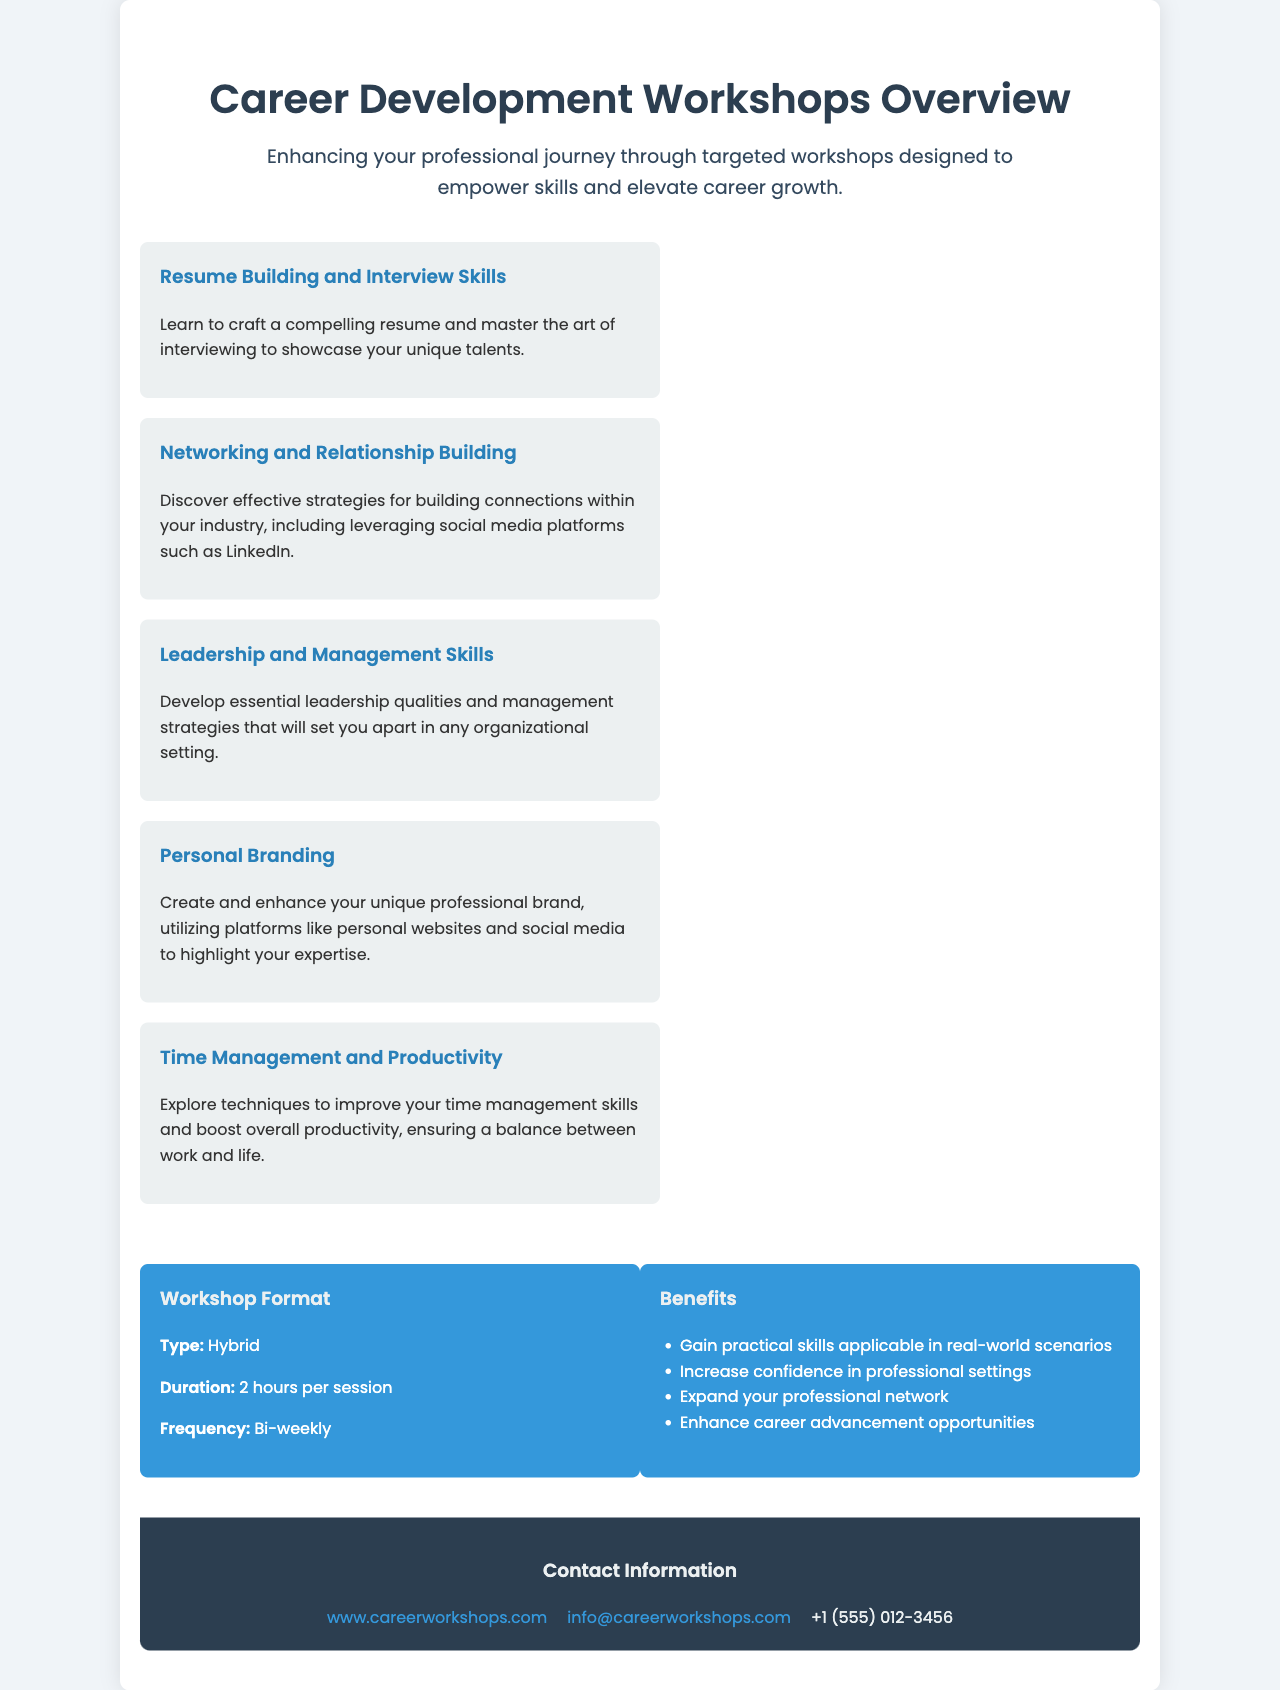What is the title of the document? The title of the document is presented at the top of the brochure.
Answer: Career Development Workshops Overview How many workshops are listed in the document? The document mentions five workshops in total, showcasing different key skills.
Answer: 5 What is the duration of each workshop session? The duration of each workshop session is specified in the format section of the document.
Answer: 2 hours What type of workshop format is mentioned? The format section indicates that the workshops have a specific type of instructional approach.
Answer: Hybrid What skill does the "Networking and Relationship Building" workshop focus on? The focus of this workshop is described in its associated description.
Answer: Building connections What is one benefit of attending these workshops? The benefits section lists several advantages of participating in the workshops.
Answer: Gain practical skills How often are the workshops held? The frequency of the workshops is mentioned in the format section, indicating how regularly they occur.
Answer: Bi-weekly What is the main goal of the Career Development Workshops? The introductory text outlines the primary purpose of the workshops for participants.
Answer: Enhance professional journey What platforms are suggested for enhancing personal branding? The description of the personal branding workshop mentions specific platforms to use.
Answer: Personal websites and social media 